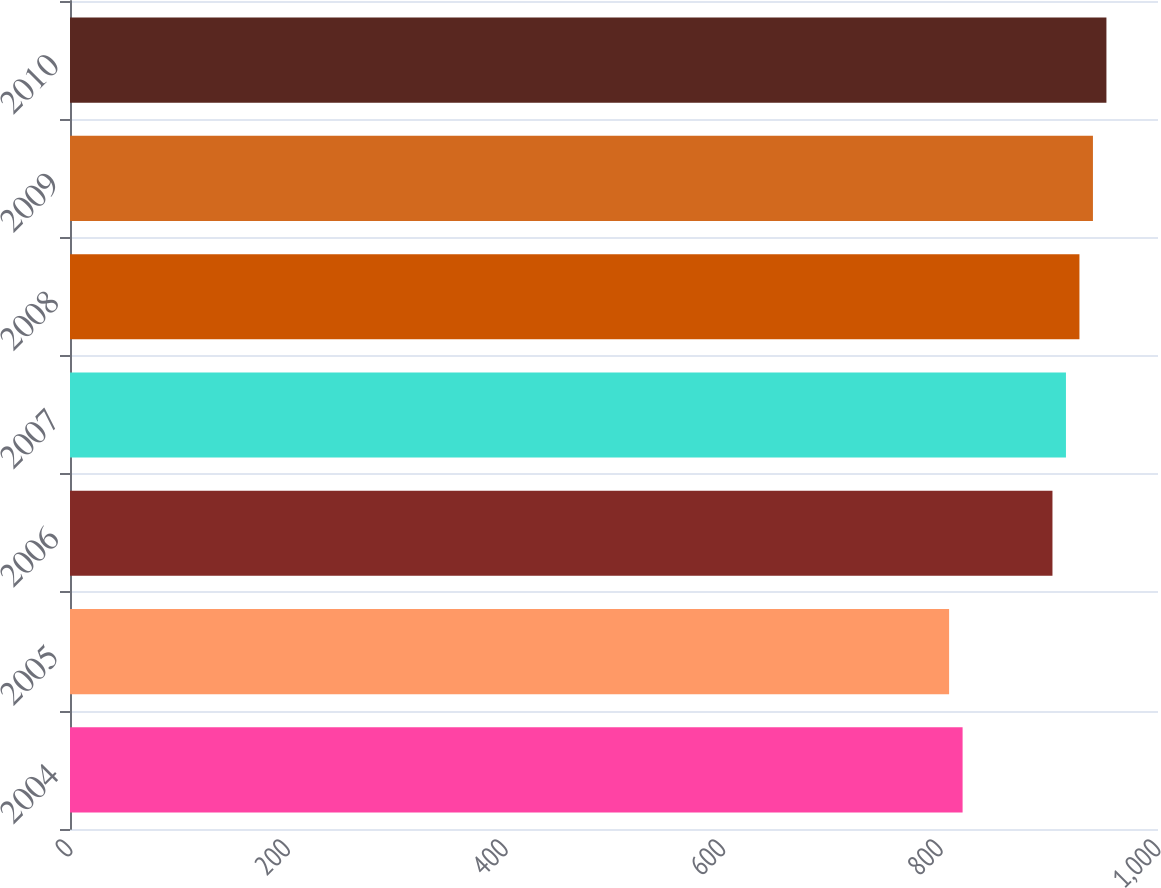Convert chart to OTSL. <chart><loc_0><loc_0><loc_500><loc_500><bar_chart><fcel>2004<fcel>2005<fcel>2006<fcel>2007<fcel>2008<fcel>2009<fcel>2010<nl><fcel>820.4<fcel>808<fcel>903<fcel>915.4<fcel>927.8<fcel>940.2<fcel>952.6<nl></chart> 